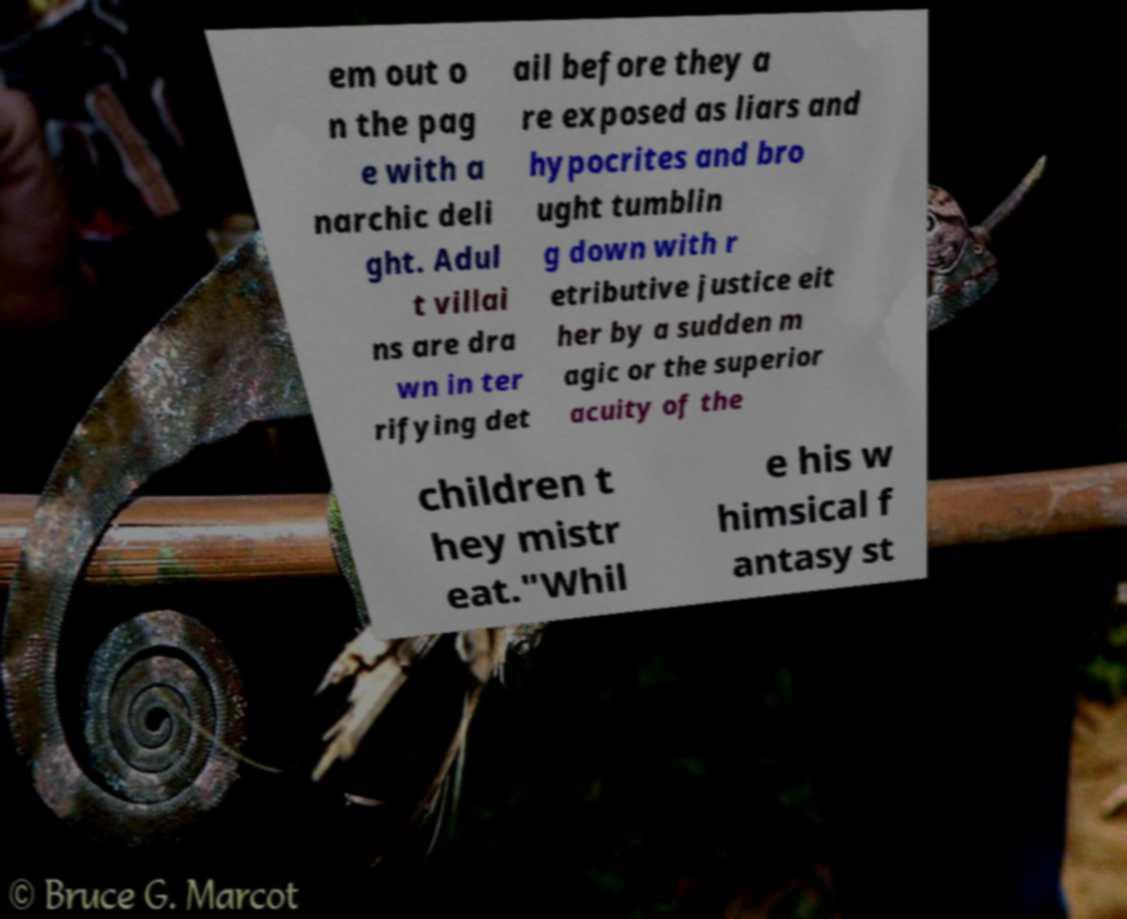I need the written content from this picture converted into text. Can you do that? em out o n the pag e with a narchic deli ght. Adul t villai ns are dra wn in ter rifying det ail before they a re exposed as liars and hypocrites and bro ught tumblin g down with r etributive justice eit her by a sudden m agic or the superior acuity of the children t hey mistr eat."Whil e his w himsical f antasy st 